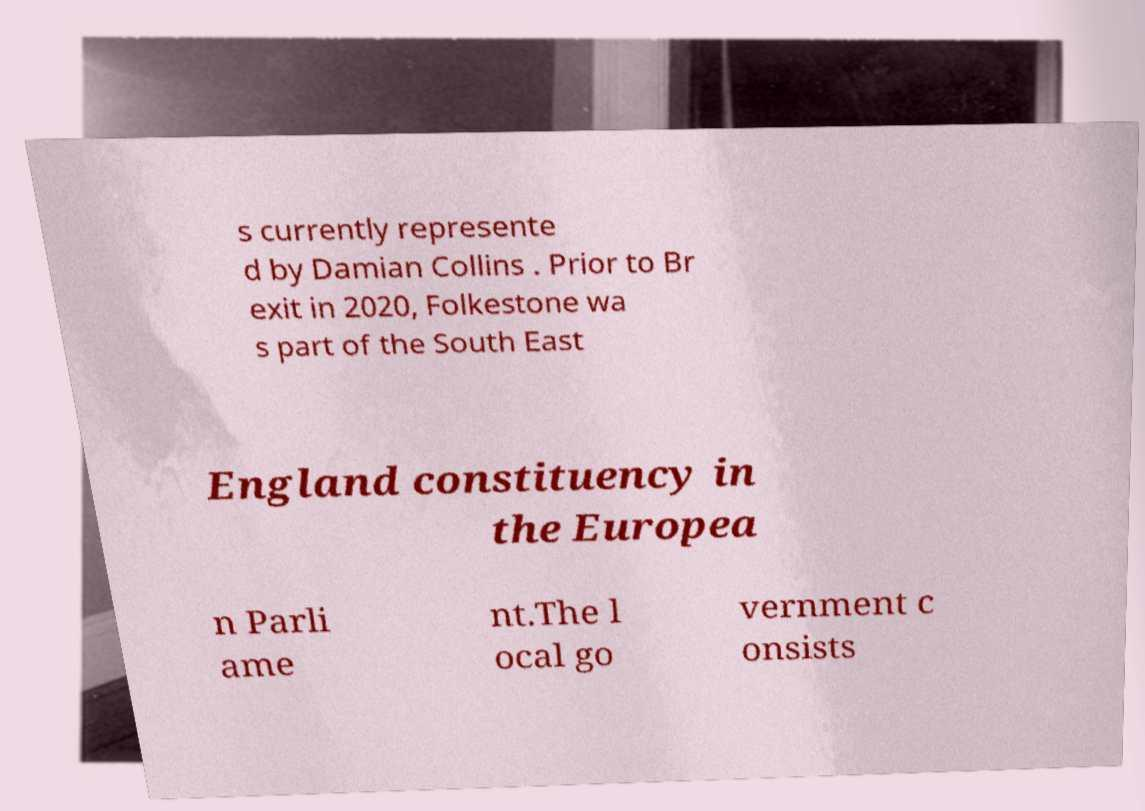What messages or text are displayed in this image? I need them in a readable, typed format. s currently represente d by Damian Collins . Prior to Br exit in 2020, Folkestone wa s part of the South East England constituency in the Europea n Parli ame nt.The l ocal go vernment c onsists 